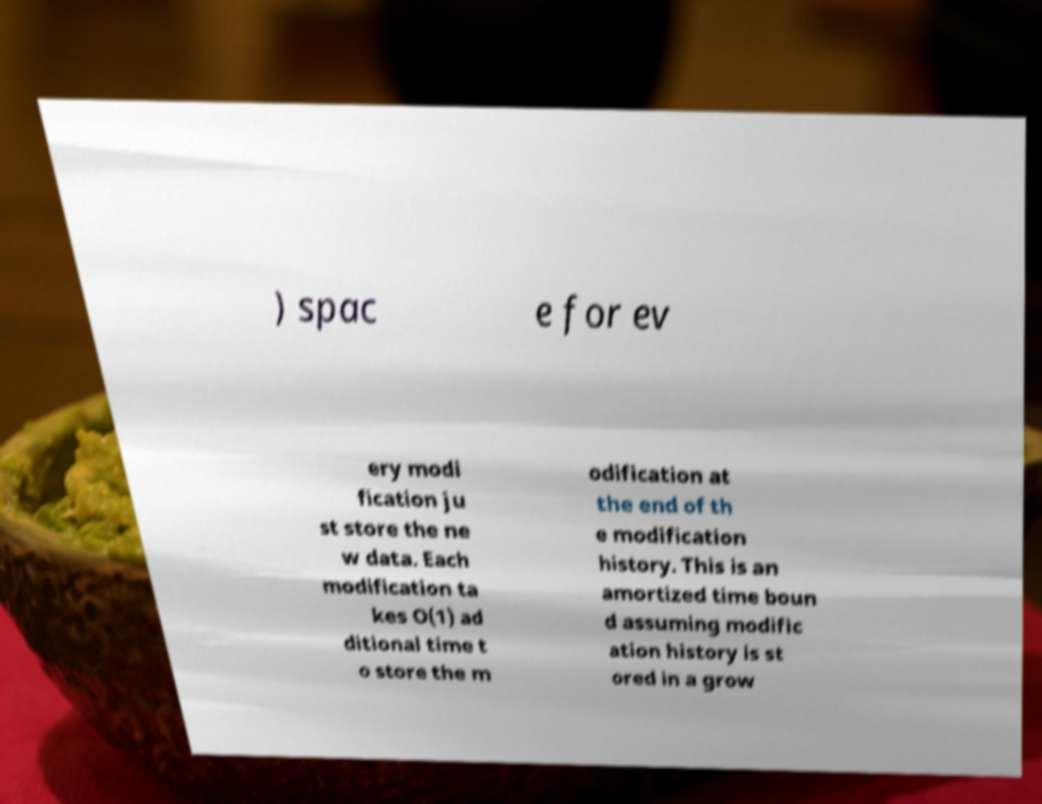I need the written content from this picture converted into text. Can you do that? ) spac e for ev ery modi fication ju st store the ne w data. Each modification ta kes O(1) ad ditional time t o store the m odification at the end of th e modification history. This is an amortized time boun d assuming modific ation history is st ored in a grow 